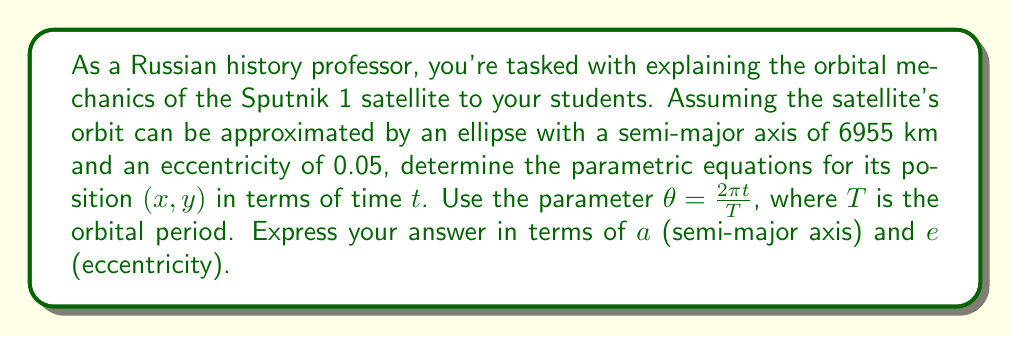Solve this math problem. Let's approach this step-by-step:

1) The general parametric equations for an ellipse centered at the origin are:
   $$x = a \cos \theta$$
   $$y = b \sin \theta$$
   where $a$ is the semi-major axis and $b$ is the semi-minor axis.

2) We need to relate $b$ to $a$ and $e$. The relationship is:
   $$b = a\sqrt{1-e^2}$$

3) However, for an elliptical orbit, the center of the Earth is at one focus, not at the center of the ellipse. We need to shift the equations by $ae$ along the x-axis:
   $$x = a \cos \theta + ae$$
   $$y = a\sqrt{1-e^2} \sin \theta$$

4) Now, we replace $\theta$ with $\frac{2\pi t}{T}$:
   $$x = a \cos (\frac{2\pi t}{T}) + ae$$
   $$y = a\sqrt{1-e^2} \sin (\frac{2\pi t}{T})$$

5) These are the parametric equations for the position of Sputnik 1 in terms of time $t$, expressed using the semi-major axis $a$ and eccentricity $e$.
Answer: $$x = a \cos (\frac{2\pi t}{T}) + ae, \quad y = a\sqrt{1-e^2} \sin (\frac{2\pi t}{T})$$ 